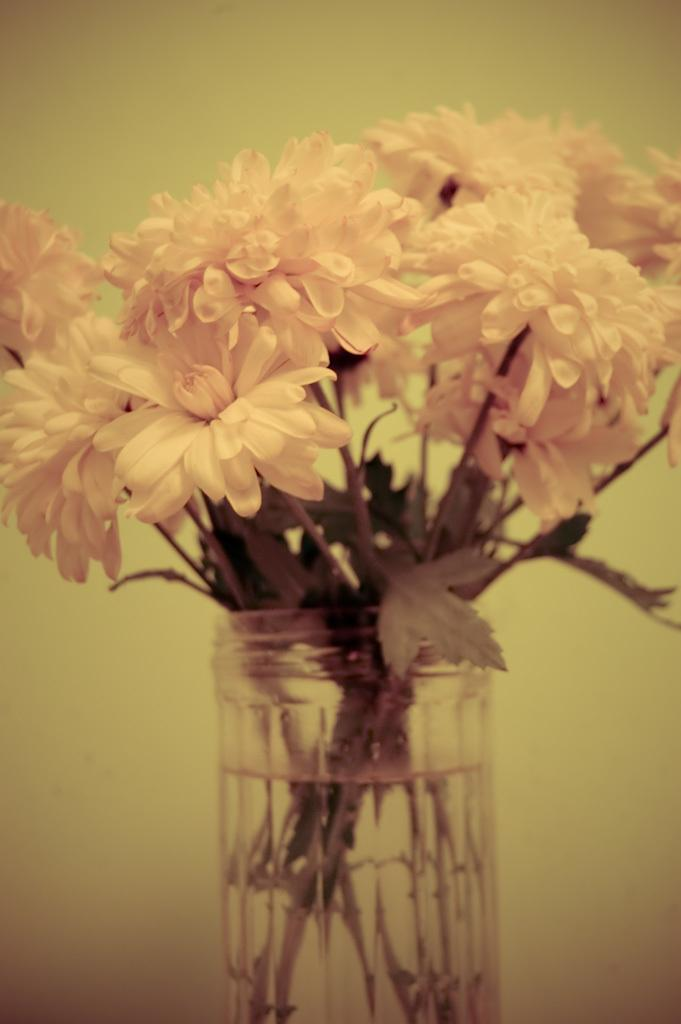What is present in the image? There are flowers in the image. How are the flowers arranged or displayed? The flowers are kept in a bottle. What is inside the bottle with the flowers? There is water in the bottle. What color are the flowers? The flowers are pink in color. Who is the writer of the payment slip in the image? There is no payment slip present in the image; it features flowers in a bottle. 